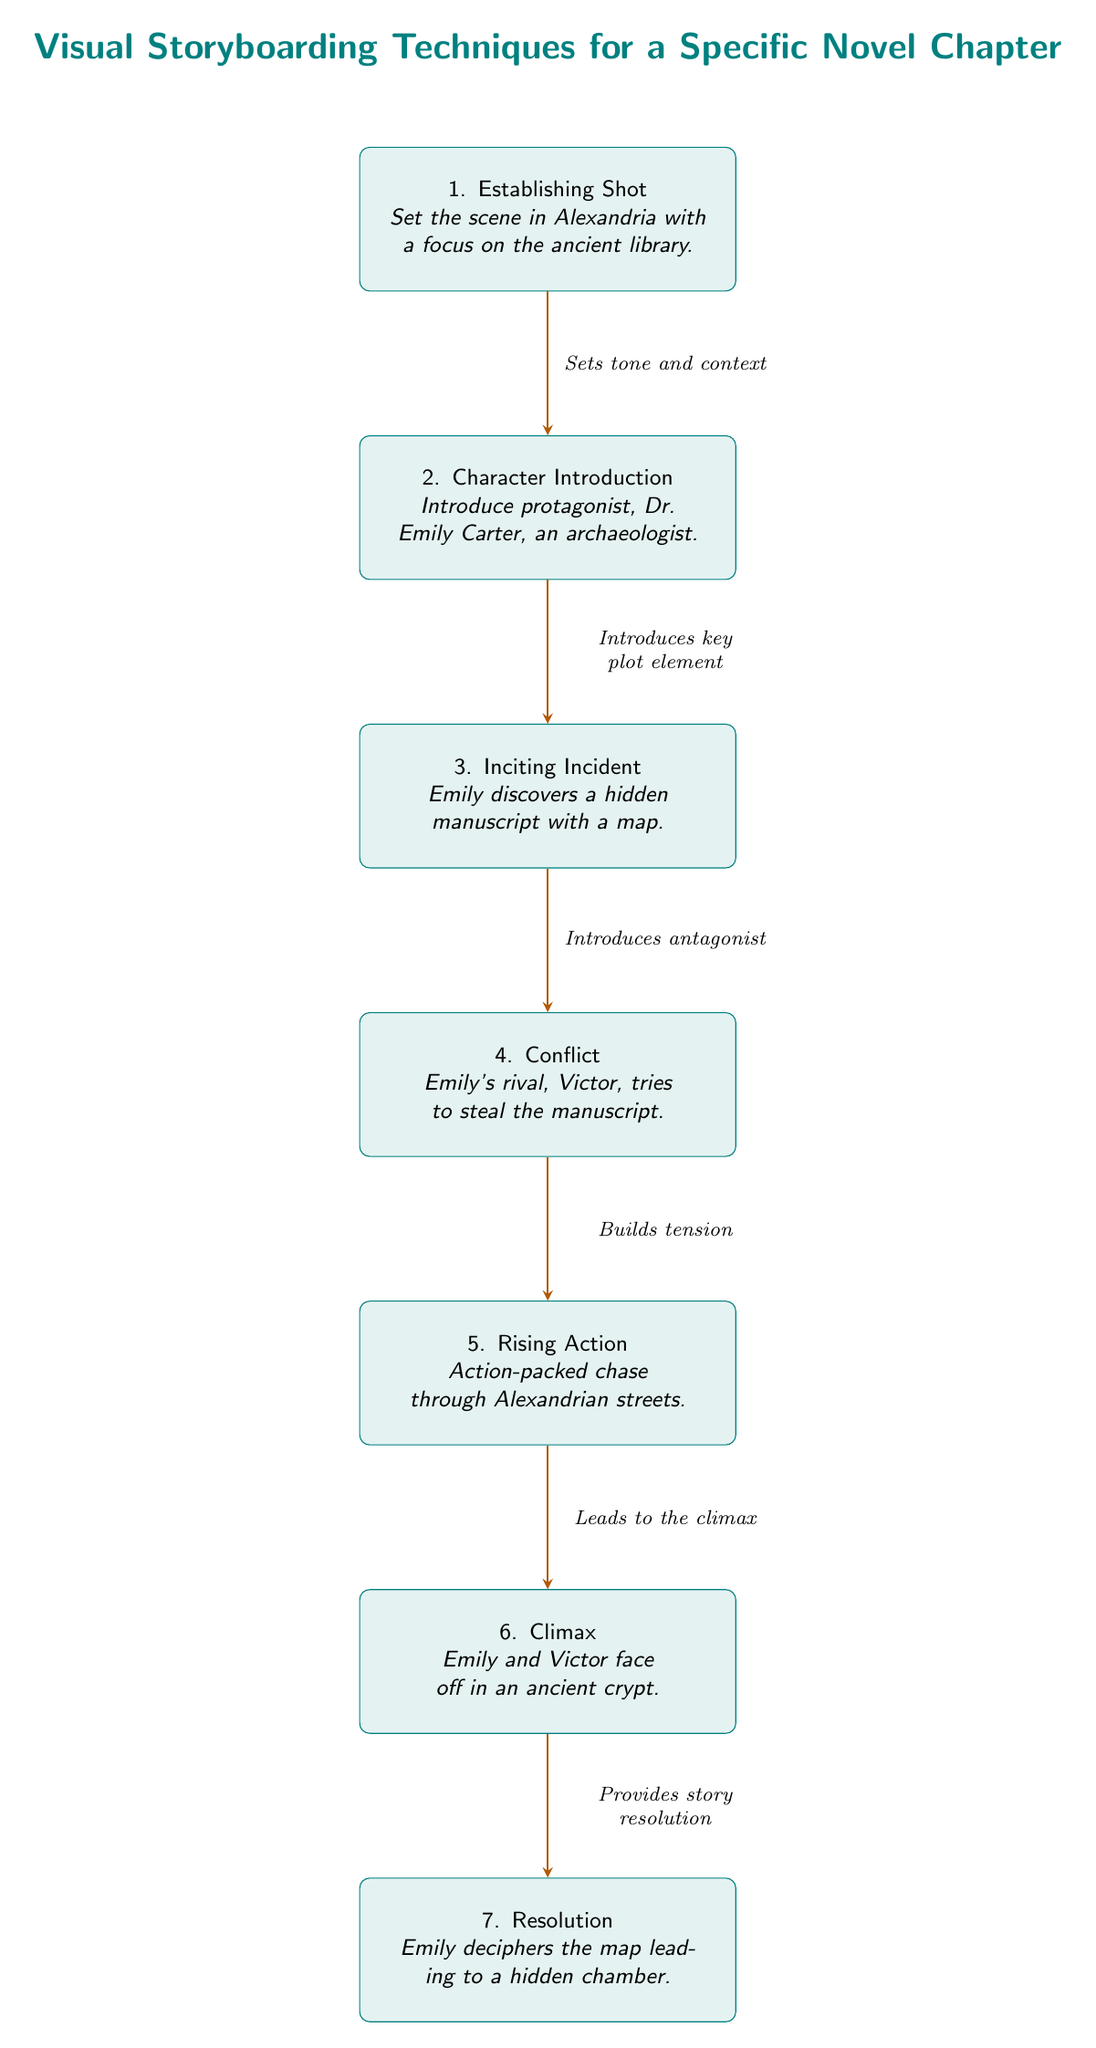What is the first step in the storyboarding process? The first step in the diagram is labeled as "1. Establishing Shot." This node presents the initial setup of the scene in Alexandria, focusing on the ancient library.
Answer: Establishing Shot How many nodes are present in the diagram? The diagram contains a total of seven nodes, each representing a distinct part of the storyboarding process.
Answer: 7 What element is introduced in the second step? The second step is titled "Character Introduction," which introduces the protagonist, Dr. Emily Carter. This is a key element that establishes the main character of the story.
Answer: Protagonist Which node represents the climax of the story? The climax is represented by the sixth node, which is titled "6. Climax." It describes the face-off between Emily and Victor in an ancient crypt, marking a pivotal moment in the narrative.
Answer: Climax What relationship does the arrow from the "Conflict" node to the "Rising Action" node indicate? The arrow indicates "Builds tension," meaning that the conflict — where Victor tries to steal the manuscript — leads to increased intensity and action in the rising action segment that follows.
Answer: Builds tension How does the "Rising Action" node lead to the climax? The arrow connects "5. Rising Action" to "6. Climax," with the label "Leads to the climax." This implies that the action-packed chase through the Alexandrian streets sets up the climactic confrontation between Emily and Victor.
Answer: Leads to the climax 